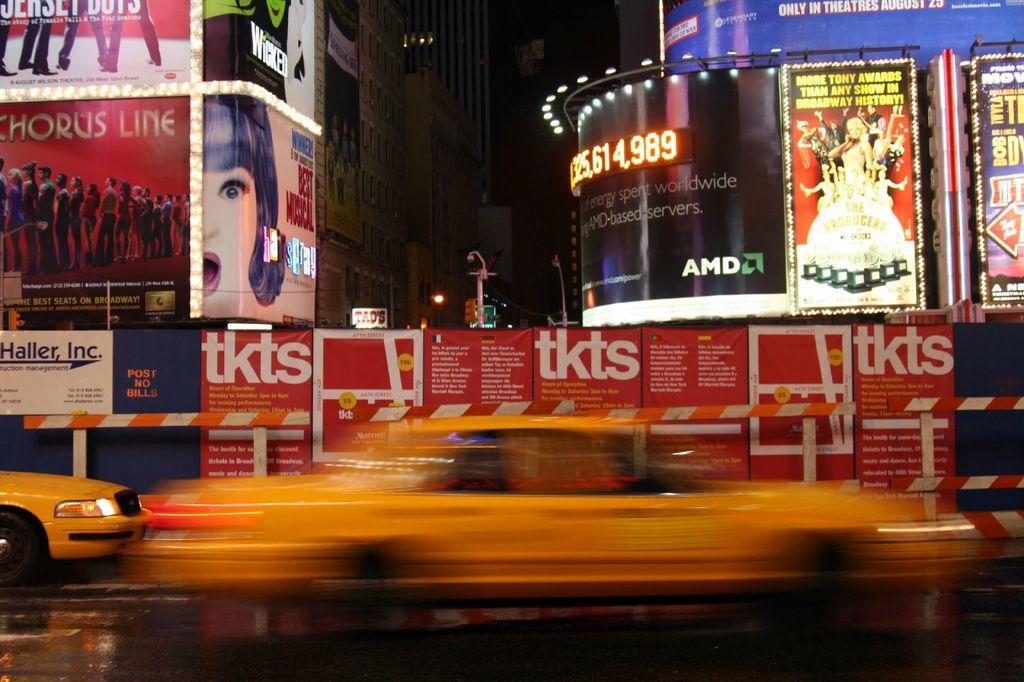Can you describe this image briefly? In this image there are vehicles in the foreground. There are posters and metal railing in the background. There are buildings on the left and right corner. And the sky is dark at the top. 